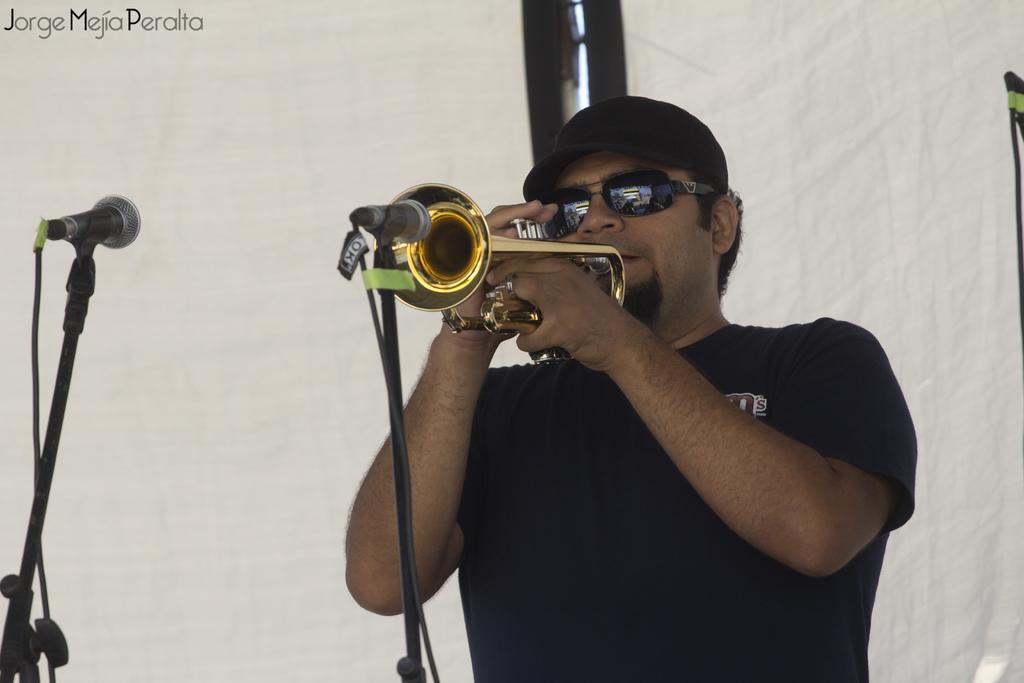In one or two sentences, can you explain what this image depicts? In this image we can see a person wearing cap and goggles. He is playing musical instrument. In front of him there are mics with stands. In the back there is curtain. In the left top corner something is written. 